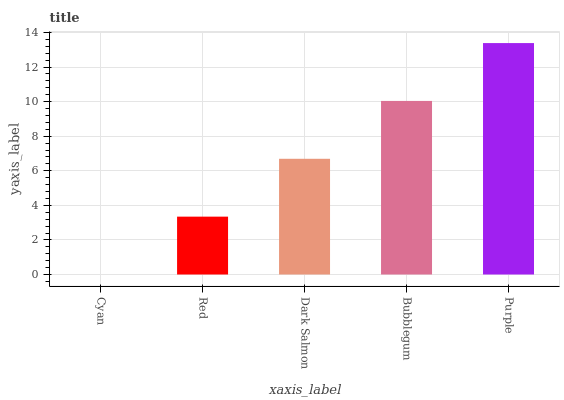Is Cyan the minimum?
Answer yes or no. Yes. Is Purple the maximum?
Answer yes or no. Yes. Is Red the minimum?
Answer yes or no. No. Is Red the maximum?
Answer yes or no. No. Is Red greater than Cyan?
Answer yes or no. Yes. Is Cyan less than Red?
Answer yes or no. Yes. Is Cyan greater than Red?
Answer yes or no. No. Is Red less than Cyan?
Answer yes or no. No. Is Dark Salmon the high median?
Answer yes or no. Yes. Is Dark Salmon the low median?
Answer yes or no. Yes. Is Red the high median?
Answer yes or no. No. Is Bubblegum the low median?
Answer yes or no. No. 